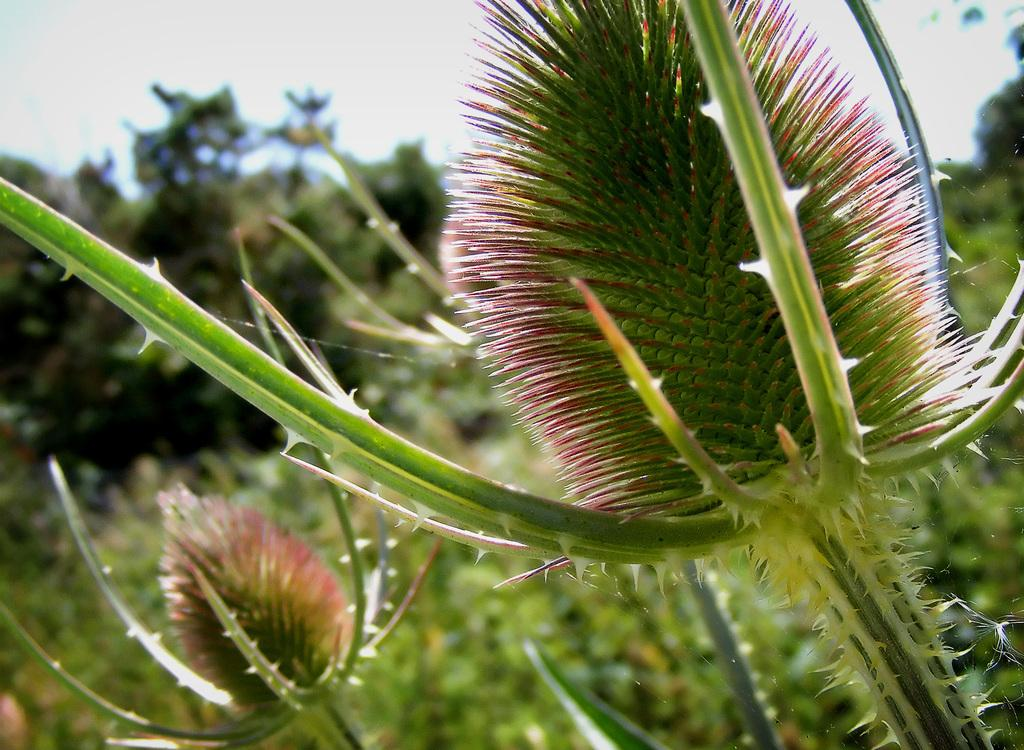What type of living organisms can be seen in the image? Plants can be seen in the image. What else is present in the image besides plants? There is a spider web in the image. How many spider webs are visible in the image? There are multiple spider webs in the image. Can you describe the background of the image? The background of the image is blurred. What type of trucks can be seen driving through the mouth in the image? There are no trucks or mouths present in the image. 